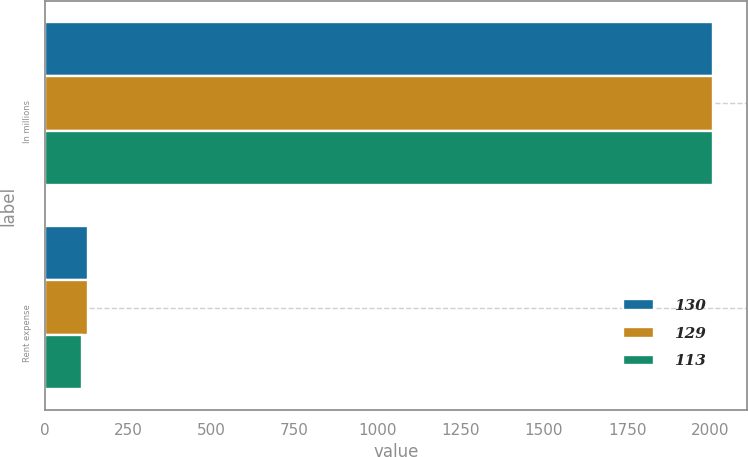Convert chart. <chart><loc_0><loc_0><loc_500><loc_500><stacked_bar_chart><ecel><fcel>In millions<fcel>Rent expense<nl><fcel>130<fcel>2009<fcel>130<nl><fcel>129<fcel>2008<fcel>129<nl><fcel>113<fcel>2007<fcel>113<nl></chart> 